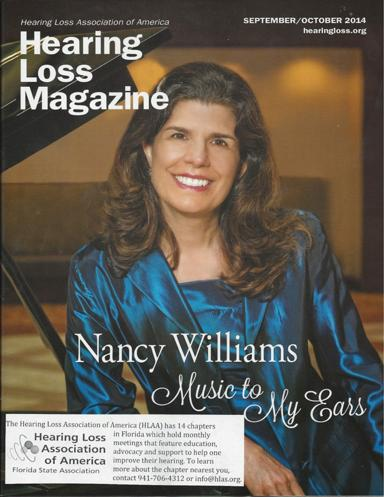What do the monthly meetings of the HLAA chapters feature? Monthly meetings organized by HLAA chapters provide invaluable resources, such as educational talks, workshops, and group support sessions, all designed to assist individuals with hearing improvement and management. 